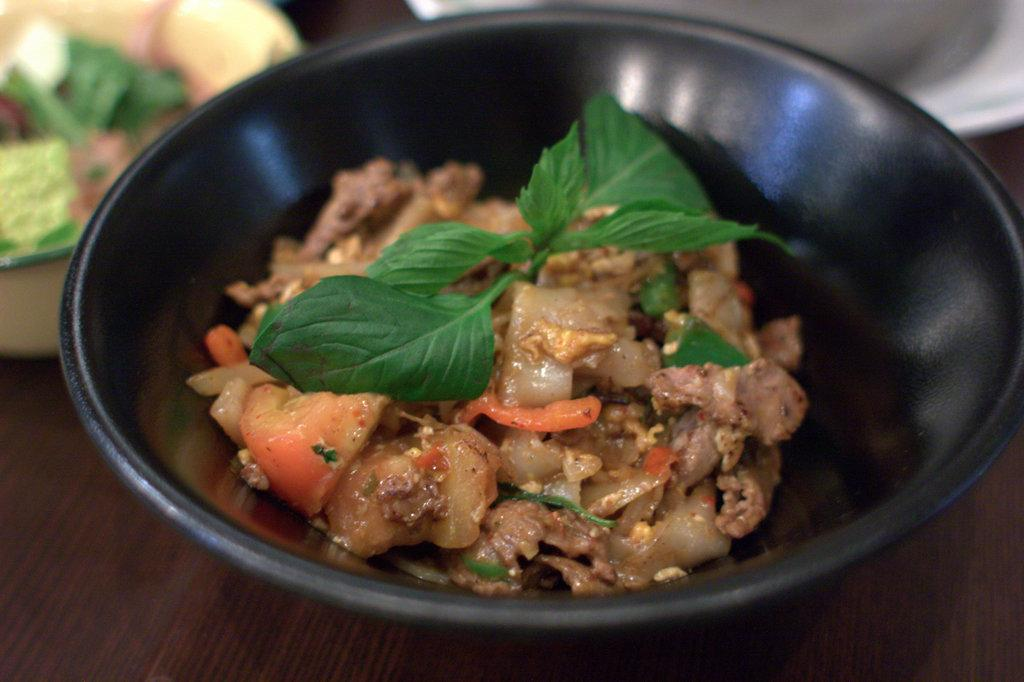What is in the bowl that is visible in the image? There is a bowl with food items in the image. What is the color of the bowl? The bowl is black in color. Can you describe any other bowls in the image? There are other items in bowls in the background of the image. What type of riddle can be solved using the details in the image? There is no riddle present in the image, as it only features a bowl with food items and other bowls in the background. 